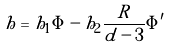Convert formula to latex. <formula><loc_0><loc_0><loc_500><loc_500>h = h _ { 1 } \Phi - h _ { 2 } \frac { R } { d - 3 } \Phi ^ { \prime }</formula> 